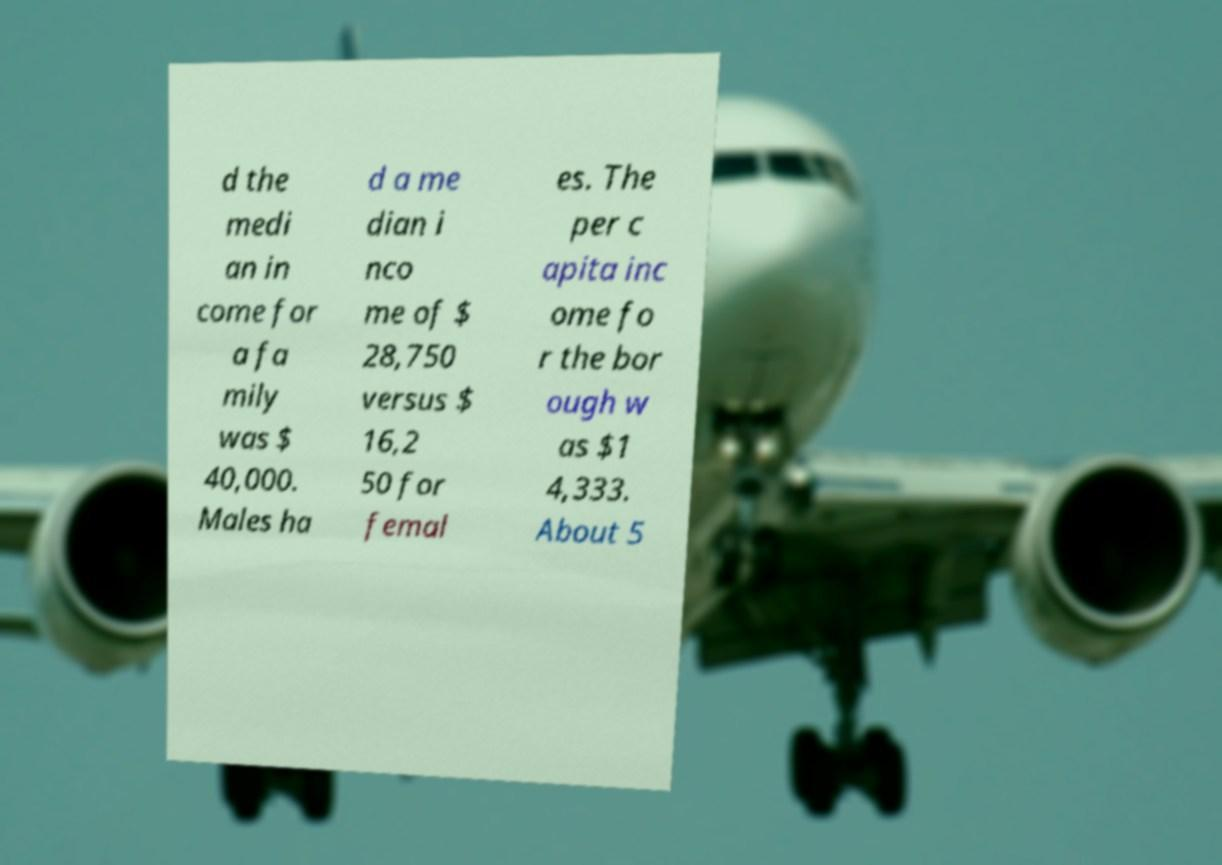There's text embedded in this image that I need extracted. Can you transcribe it verbatim? d the medi an in come for a fa mily was $ 40,000. Males ha d a me dian i nco me of $ 28,750 versus $ 16,2 50 for femal es. The per c apita inc ome fo r the bor ough w as $1 4,333. About 5 